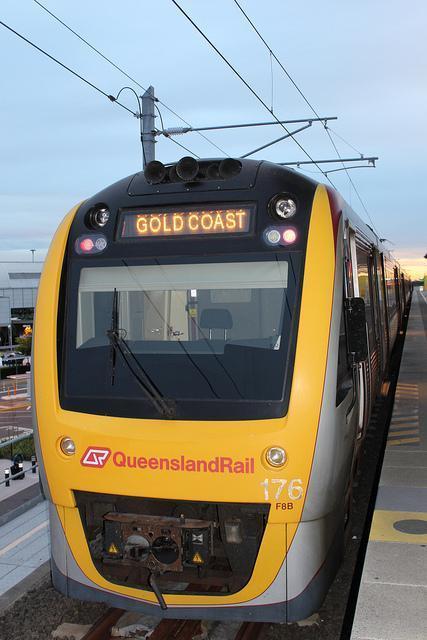How many people are not holding a surfboard?
Give a very brief answer. 0. 